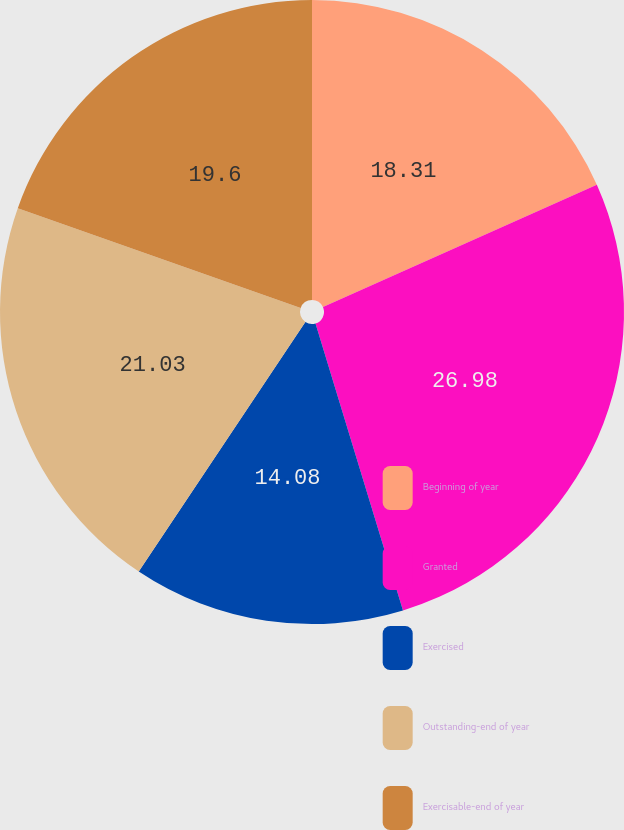Convert chart. <chart><loc_0><loc_0><loc_500><loc_500><pie_chart><fcel>Beginning of year<fcel>Granted<fcel>Exercised<fcel>Outstanding-end of year<fcel>Exercisable-end of year<nl><fcel>18.31%<fcel>26.98%<fcel>14.08%<fcel>21.03%<fcel>19.6%<nl></chart> 